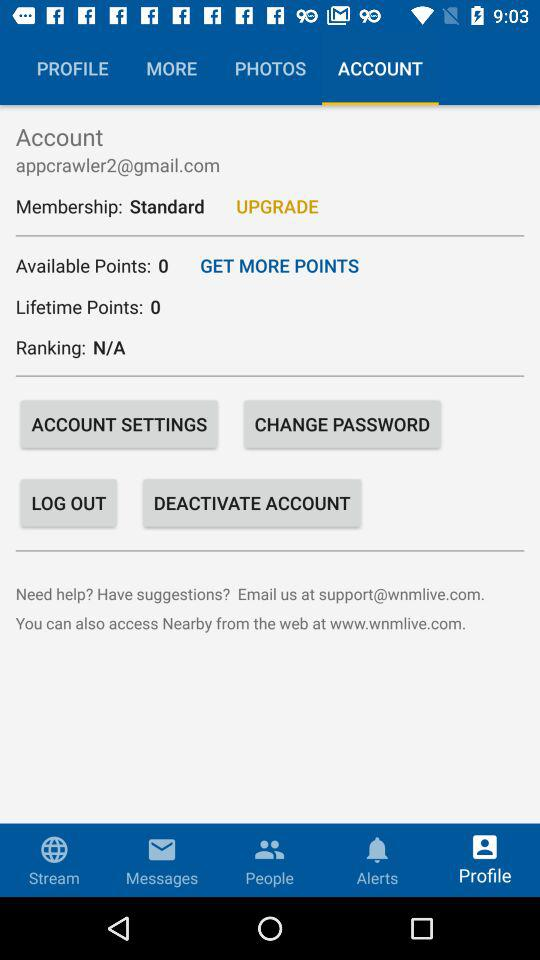What is the ranking? The ranking is "N/A". 